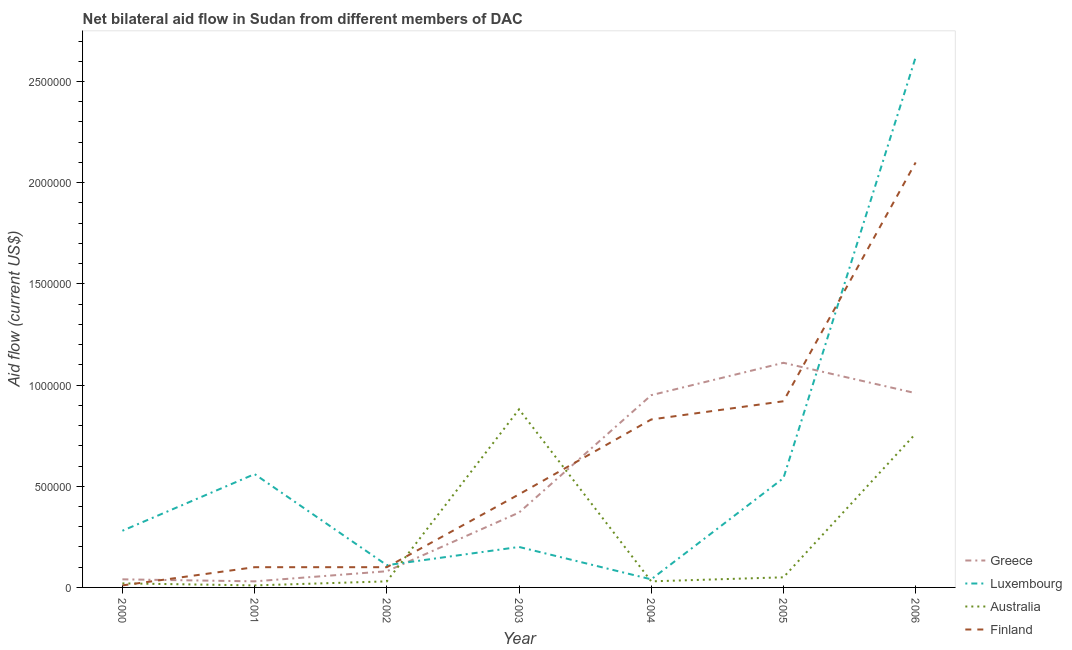How many different coloured lines are there?
Provide a succinct answer. 4. Does the line corresponding to amount of aid given by finland intersect with the line corresponding to amount of aid given by greece?
Your response must be concise. Yes. What is the amount of aid given by luxembourg in 2003?
Keep it short and to the point. 2.00e+05. Across all years, what is the maximum amount of aid given by australia?
Offer a terse response. 8.80e+05. Across all years, what is the minimum amount of aid given by australia?
Offer a very short reply. 10000. In which year was the amount of aid given by luxembourg minimum?
Your response must be concise. 2004. What is the total amount of aid given by australia in the graph?
Your response must be concise. 1.78e+06. What is the difference between the amount of aid given by luxembourg in 2000 and that in 2005?
Provide a short and direct response. -2.60e+05. What is the difference between the amount of aid given by luxembourg in 2004 and the amount of aid given by australia in 2005?
Offer a very short reply. -10000. What is the average amount of aid given by finland per year?
Offer a terse response. 6.46e+05. In the year 2001, what is the difference between the amount of aid given by greece and amount of aid given by finland?
Make the answer very short. -7.00e+04. What is the ratio of the amount of aid given by luxembourg in 2003 to that in 2004?
Offer a very short reply. 5. Is the amount of aid given by finland in 2000 less than that in 2004?
Your answer should be very brief. Yes. What is the difference between the highest and the second highest amount of aid given by luxembourg?
Give a very brief answer. 2.06e+06. What is the difference between the highest and the lowest amount of aid given by australia?
Your answer should be compact. 8.70e+05. In how many years, is the amount of aid given by australia greater than the average amount of aid given by australia taken over all years?
Give a very brief answer. 2. Is the sum of the amount of aid given by australia in 2001 and 2003 greater than the maximum amount of aid given by greece across all years?
Your answer should be compact. No. Is it the case that in every year, the sum of the amount of aid given by greece and amount of aid given by luxembourg is greater than the amount of aid given by australia?
Your answer should be very brief. No. Is the amount of aid given by luxembourg strictly less than the amount of aid given by australia over the years?
Your answer should be compact. No. How many lines are there?
Provide a short and direct response. 4. How many years are there in the graph?
Give a very brief answer. 7. What is the difference between two consecutive major ticks on the Y-axis?
Your answer should be very brief. 5.00e+05. Are the values on the major ticks of Y-axis written in scientific E-notation?
Offer a very short reply. No. How many legend labels are there?
Keep it short and to the point. 4. How are the legend labels stacked?
Provide a succinct answer. Vertical. What is the title of the graph?
Provide a succinct answer. Net bilateral aid flow in Sudan from different members of DAC. Does "Overall level" appear as one of the legend labels in the graph?
Your answer should be very brief. No. What is the label or title of the X-axis?
Your answer should be compact. Year. What is the Aid flow (current US$) in Finland in 2000?
Offer a terse response. 10000. What is the Aid flow (current US$) in Luxembourg in 2001?
Provide a succinct answer. 5.60e+05. What is the Aid flow (current US$) of Finland in 2001?
Ensure brevity in your answer.  1.00e+05. What is the Aid flow (current US$) in Greece in 2002?
Your answer should be very brief. 8.00e+04. What is the Aid flow (current US$) in Australia in 2003?
Ensure brevity in your answer.  8.80e+05. What is the Aid flow (current US$) of Greece in 2004?
Make the answer very short. 9.50e+05. What is the Aid flow (current US$) in Australia in 2004?
Offer a terse response. 3.00e+04. What is the Aid flow (current US$) of Finland in 2004?
Provide a succinct answer. 8.30e+05. What is the Aid flow (current US$) of Greece in 2005?
Your answer should be compact. 1.11e+06. What is the Aid flow (current US$) of Luxembourg in 2005?
Keep it short and to the point. 5.40e+05. What is the Aid flow (current US$) of Finland in 2005?
Give a very brief answer. 9.20e+05. What is the Aid flow (current US$) of Greece in 2006?
Ensure brevity in your answer.  9.60e+05. What is the Aid flow (current US$) of Luxembourg in 2006?
Make the answer very short. 2.62e+06. What is the Aid flow (current US$) in Australia in 2006?
Keep it short and to the point. 7.60e+05. What is the Aid flow (current US$) in Finland in 2006?
Your answer should be very brief. 2.10e+06. Across all years, what is the maximum Aid flow (current US$) in Greece?
Make the answer very short. 1.11e+06. Across all years, what is the maximum Aid flow (current US$) of Luxembourg?
Your answer should be very brief. 2.62e+06. Across all years, what is the maximum Aid flow (current US$) in Australia?
Ensure brevity in your answer.  8.80e+05. Across all years, what is the maximum Aid flow (current US$) in Finland?
Give a very brief answer. 2.10e+06. Across all years, what is the minimum Aid flow (current US$) in Greece?
Offer a terse response. 3.00e+04. Across all years, what is the minimum Aid flow (current US$) of Australia?
Offer a terse response. 10000. What is the total Aid flow (current US$) in Greece in the graph?
Ensure brevity in your answer.  3.54e+06. What is the total Aid flow (current US$) in Luxembourg in the graph?
Make the answer very short. 4.35e+06. What is the total Aid flow (current US$) of Australia in the graph?
Ensure brevity in your answer.  1.78e+06. What is the total Aid flow (current US$) in Finland in the graph?
Ensure brevity in your answer.  4.52e+06. What is the difference between the Aid flow (current US$) of Luxembourg in 2000 and that in 2001?
Offer a very short reply. -2.80e+05. What is the difference between the Aid flow (current US$) in Australia in 2000 and that in 2001?
Keep it short and to the point. 10000. What is the difference between the Aid flow (current US$) in Finland in 2000 and that in 2001?
Your answer should be compact. -9.00e+04. What is the difference between the Aid flow (current US$) of Luxembourg in 2000 and that in 2002?
Your response must be concise. 1.70e+05. What is the difference between the Aid flow (current US$) in Australia in 2000 and that in 2002?
Your answer should be very brief. -10000. What is the difference between the Aid flow (current US$) in Greece in 2000 and that in 2003?
Your answer should be very brief. -3.30e+05. What is the difference between the Aid flow (current US$) in Australia in 2000 and that in 2003?
Offer a very short reply. -8.60e+05. What is the difference between the Aid flow (current US$) in Finland in 2000 and that in 2003?
Give a very brief answer. -4.50e+05. What is the difference between the Aid flow (current US$) in Greece in 2000 and that in 2004?
Keep it short and to the point. -9.10e+05. What is the difference between the Aid flow (current US$) in Luxembourg in 2000 and that in 2004?
Your answer should be very brief. 2.40e+05. What is the difference between the Aid flow (current US$) in Australia in 2000 and that in 2004?
Your response must be concise. -10000. What is the difference between the Aid flow (current US$) of Finland in 2000 and that in 2004?
Keep it short and to the point. -8.20e+05. What is the difference between the Aid flow (current US$) of Greece in 2000 and that in 2005?
Offer a very short reply. -1.07e+06. What is the difference between the Aid flow (current US$) in Finland in 2000 and that in 2005?
Ensure brevity in your answer.  -9.10e+05. What is the difference between the Aid flow (current US$) of Greece in 2000 and that in 2006?
Your response must be concise. -9.20e+05. What is the difference between the Aid flow (current US$) of Luxembourg in 2000 and that in 2006?
Your answer should be very brief. -2.34e+06. What is the difference between the Aid flow (current US$) of Australia in 2000 and that in 2006?
Keep it short and to the point. -7.40e+05. What is the difference between the Aid flow (current US$) in Finland in 2000 and that in 2006?
Give a very brief answer. -2.09e+06. What is the difference between the Aid flow (current US$) of Australia in 2001 and that in 2002?
Offer a terse response. -2.00e+04. What is the difference between the Aid flow (current US$) in Finland in 2001 and that in 2002?
Keep it short and to the point. 0. What is the difference between the Aid flow (current US$) in Greece in 2001 and that in 2003?
Your response must be concise. -3.40e+05. What is the difference between the Aid flow (current US$) of Luxembourg in 2001 and that in 2003?
Give a very brief answer. 3.60e+05. What is the difference between the Aid flow (current US$) in Australia in 2001 and that in 2003?
Provide a short and direct response. -8.70e+05. What is the difference between the Aid flow (current US$) in Finland in 2001 and that in 2003?
Provide a short and direct response. -3.60e+05. What is the difference between the Aid flow (current US$) of Greece in 2001 and that in 2004?
Provide a succinct answer. -9.20e+05. What is the difference between the Aid flow (current US$) of Luxembourg in 2001 and that in 2004?
Keep it short and to the point. 5.20e+05. What is the difference between the Aid flow (current US$) in Finland in 2001 and that in 2004?
Offer a terse response. -7.30e+05. What is the difference between the Aid flow (current US$) of Greece in 2001 and that in 2005?
Give a very brief answer. -1.08e+06. What is the difference between the Aid flow (current US$) in Australia in 2001 and that in 2005?
Make the answer very short. -4.00e+04. What is the difference between the Aid flow (current US$) in Finland in 2001 and that in 2005?
Your answer should be compact. -8.20e+05. What is the difference between the Aid flow (current US$) of Greece in 2001 and that in 2006?
Give a very brief answer. -9.30e+05. What is the difference between the Aid flow (current US$) of Luxembourg in 2001 and that in 2006?
Your answer should be very brief. -2.06e+06. What is the difference between the Aid flow (current US$) of Australia in 2001 and that in 2006?
Offer a terse response. -7.50e+05. What is the difference between the Aid flow (current US$) of Finland in 2001 and that in 2006?
Offer a very short reply. -2.00e+06. What is the difference between the Aid flow (current US$) in Greece in 2002 and that in 2003?
Your answer should be compact. -2.90e+05. What is the difference between the Aid flow (current US$) in Australia in 2002 and that in 2003?
Make the answer very short. -8.50e+05. What is the difference between the Aid flow (current US$) in Finland in 2002 and that in 2003?
Provide a succinct answer. -3.60e+05. What is the difference between the Aid flow (current US$) in Greece in 2002 and that in 2004?
Provide a succinct answer. -8.70e+05. What is the difference between the Aid flow (current US$) in Luxembourg in 2002 and that in 2004?
Keep it short and to the point. 7.00e+04. What is the difference between the Aid flow (current US$) in Finland in 2002 and that in 2004?
Offer a terse response. -7.30e+05. What is the difference between the Aid flow (current US$) in Greece in 2002 and that in 2005?
Keep it short and to the point. -1.03e+06. What is the difference between the Aid flow (current US$) in Luxembourg in 2002 and that in 2005?
Offer a terse response. -4.30e+05. What is the difference between the Aid flow (current US$) of Finland in 2002 and that in 2005?
Your answer should be compact. -8.20e+05. What is the difference between the Aid flow (current US$) in Greece in 2002 and that in 2006?
Your answer should be very brief. -8.80e+05. What is the difference between the Aid flow (current US$) in Luxembourg in 2002 and that in 2006?
Make the answer very short. -2.51e+06. What is the difference between the Aid flow (current US$) in Australia in 2002 and that in 2006?
Ensure brevity in your answer.  -7.30e+05. What is the difference between the Aid flow (current US$) in Greece in 2003 and that in 2004?
Keep it short and to the point. -5.80e+05. What is the difference between the Aid flow (current US$) in Luxembourg in 2003 and that in 2004?
Offer a very short reply. 1.60e+05. What is the difference between the Aid flow (current US$) of Australia in 2003 and that in 2004?
Make the answer very short. 8.50e+05. What is the difference between the Aid flow (current US$) in Finland in 2003 and that in 2004?
Your response must be concise. -3.70e+05. What is the difference between the Aid flow (current US$) of Greece in 2003 and that in 2005?
Your response must be concise. -7.40e+05. What is the difference between the Aid flow (current US$) of Luxembourg in 2003 and that in 2005?
Your answer should be very brief. -3.40e+05. What is the difference between the Aid flow (current US$) of Australia in 2003 and that in 2005?
Provide a succinct answer. 8.30e+05. What is the difference between the Aid flow (current US$) of Finland in 2003 and that in 2005?
Provide a succinct answer. -4.60e+05. What is the difference between the Aid flow (current US$) in Greece in 2003 and that in 2006?
Offer a very short reply. -5.90e+05. What is the difference between the Aid flow (current US$) of Luxembourg in 2003 and that in 2006?
Provide a short and direct response. -2.42e+06. What is the difference between the Aid flow (current US$) in Australia in 2003 and that in 2006?
Make the answer very short. 1.20e+05. What is the difference between the Aid flow (current US$) of Finland in 2003 and that in 2006?
Provide a succinct answer. -1.64e+06. What is the difference between the Aid flow (current US$) of Luxembourg in 2004 and that in 2005?
Offer a terse response. -5.00e+05. What is the difference between the Aid flow (current US$) of Greece in 2004 and that in 2006?
Provide a succinct answer. -10000. What is the difference between the Aid flow (current US$) of Luxembourg in 2004 and that in 2006?
Your response must be concise. -2.58e+06. What is the difference between the Aid flow (current US$) of Australia in 2004 and that in 2006?
Your answer should be very brief. -7.30e+05. What is the difference between the Aid flow (current US$) in Finland in 2004 and that in 2006?
Provide a succinct answer. -1.27e+06. What is the difference between the Aid flow (current US$) in Greece in 2005 and that in 2006?
Offer a terse response. 1.50e+05. What is the difference between the Aid flow (current US$) of Luxembourg in 2005 and that in 2006?
Provide a short and direct response. -2.08e+06. What is the difference between the Aid flow (current US$) of Australia in 2005 and that in 2006?
Offer a terse response. -7.10e+05. What is the difference between the Aid flow (current US$) of Finland in 2005 and that in 2006?
Give a very brief answer. -1.18e+06. What is the difference between the Aid flow (current US$) of Greece in 2000 and the Aid flow (current US$) of Luxembourg in 2001?
Offer a terse response. -5.20e+05. What is the difference between the Aid flow (current US$) in Greece in 2000 and the Aid flow (current US$) in Australia in 2001?
Provide a succinct answer. 3.00e+04. What is the difference between the Aid flow (current US$) of Greece in 2000 and the Aid flow (current US$) of Finland in 2001?
Your answer should be compact. -6.00e+04. What is the difference between the Aid flow (current US$) in Luxembourg in 2000 and the Aid flow (current US$) in Australia in 2001?
Offer a terse response. 2.70e+05. What is the difference between the Aid flow (current US$) in Greece in 2000 and the Aid flow (current US$) in Luxembourg in 2002?
Offer a terse response. -7.00e+04. What is the difference between the Aid flow (current US$) of Greece in 2000 and the Aid flow (current US$) of Finland in 2002?
Offer a very short reply. -6.00e+04. What is the difference between the Aid flow (current US$) in Luxembourg in 2000 and the Aid flow (current US$) in Australia in 2002?
Your answer should be very brief. 2.50e+05. What is the difference between the Aid flow (current US$) in Luxembourg in 2000 and the Aid flow (current US$) in Finland in 2002?
Keep it short and to the point. 1.80e+05. What is the difference between the Aid flow (current US$) in Greece in 2000 and the Aid flow (current US$) in Luxembourg in 2003?
Your answer should be compact. -1.60e+05. What is the difference between the Aid flow (current US$) of Greece in 2000 and the Aid flow (current US$) of Australia in 2003?
Ensure brevity in your answer.  -8.40e+05. What is the difference between the Aid flow (current US$) in Greece in 2000 and the Aid flow (current US$) in Finland in 2003?
Offer a very short reply. -4.20e+05. What is the difference between the Aid flow (current US$) of Luxembourg in 2000 and the Aid flow (current US$) of Australia in 2003?
Ensure brevity in your answer.  -6.00e+05. What is the difference between the Aid flow (current US$) in Australia in 2000 and the Aid flow (current US$) in Finland in 2003?
Your answer should be compact. -4.40e+05. What is the difference between the Aid flow (current US$) in Greece in 2000 and the Aid flow (current US$) in Luxembourg in 2004?
Keep it short and to the point. 0. What is the difference between the Aid flow (current US$) of Greece in 2000 and the Aid flow (current US$) of Australia in 2004?
Provide a succinct answer. 10000. What is the difference between the Aid flow (current US$) in Greece in 2000 and the Aid flow (current US$) in Finland in 2004?
Provide a succinct answer. -7.90e+05. What is the difference between the Aid flow (current US$) of Luxembourg in 2000 and the Aid flow (current US$) of Finland in 2004?
Give a very brief answer. -5.50e+05. What is the difference between the Aid flow (current US$) in Australia in 2000 and the Aid flow (current US$) in Finland in 2004?
Make the answer very short. -8.10e+05. What is the difference between the Aid flow (current US$) of Greece in 2000 and the Aid flow (current US$) of Luxembourg in 2005?
Your answer should be very brief. -5.00e+05. What is the difference between the Aid flow (current US$) of Greece in 2000 and the Aid flow (current US$) of Australia in 2005?
Your response must be concise. -10000. What is the difference between the Aid flow (current US$) in Greece in 2000 and the Aid flow (current US$) in Finland in 2005?
Your response must be concise. -8.80e+05. What is the difference between the Aid flow (current US$) of Luxembourg in 2000 and the Aid flow (current US$) of Finland in 2005?
Provide a succinct answer. -6.40e+05. What is the difference between the Aid flow (current US$) in Australia in 2000 and the Aid flow (current US$) in Finland in 2005?
Your answer should be compact. -9.00e+05. What is the difference between the Aid flow (current US$) of Greece in 2000 and the Aid flow (current US$) of Luxembourg in 2006?
Make the answer very short. -2.58e+06. What is the difference between the Aid flow (current US$) in Greece in 2000 and the Aid flow (current US$) in Australia in 2006?
Offer a terse response. -7.20e+05. What is the difference between the Aid flow (current US$) in Greece in 2000 and the Aid flow (current US$) in Finland in 2006?
Your answer should be compact. -2.06e+06. What is the difference between the Aid flow (current US$) in Luxembourg in 2000 and the Aid flow (current US$) in Australia in 2006?
Your response must be concise. -4.80e+05. What is the difference between the Aid flow (current US$) in Luxembourg in 2000 and the Aid flow (current US$) in Finland in 2006?
Provide a succinct answer. -1.82e+06. What is the difference between the Aid flow (current US$) of Australia in 2000 and the Aid flow (current US$) of Finland in 2006?
Ensure brevity in your answer.  -2.08e+06. What is the difference between the Aid flow (current US$) in Greece in 2001 and the Aid flow (current US$) in Australia in 2002?
Provide a short and direct response. 0. What is the difference between the Aid flow (current US$) in Greece in 2001 and the Aid flow (current US$) in Finland in 2002?
Your answer should be very brief. -7.00e+04. What is the difference between the Aid flow (current US$) of Luxembourg in 2001 and the Aid flow (current US$) of Australia in 2002?
Ensure brevity in your answer.  5.30e+05. What is the difference between the Aid flow (current US$) of Luxembourg in 2001 and the Aid flow (current US$) of Finland in 2002?
Offer a very short reply. 4.60e+05. What is the difference between the Aid flow (current US$) of Australia in 2001 and the Aid flow (current US$) of Finland in 2002?
Keep it short and to the point. -9.00e+04. What is the difference between the Aid flow (current US$) of Greece in 2001 and the Aid flow (current US$) of Australia in 2003?
Give a very brief answer. -8.50e+05. What is the difference between the Aid flow (current US$) in Greece in 2001 and the Aid flow (current US$) in Finland in 2003?
Provide a short and direct response. -4.30e+05. What is the difference between the Aid flow (current US$) of Luxembourg in 2001 and the Aid flow (current US$) of Australia in 2003?
Provide a short and direct response. -3.20e+05. What is the difference between the Aid flow (current US$) of Luxembourg in 2001 and the Aid flow (current US$) of Finland in 2003?
Your answer should be very brief. 1.00e+05. What is the difference between the Aid flow (current US$) in Australia in 2001 and the Aid flow (current US$) in Finland in 2003?
Make the answer very short. -4.50e+05. What is the difference between the Aid flow (current US$) in Greece in 2001 and the Aid flow (current US$) in Finland in 2004?
Ensure brevity in your answer.  -8.00e+05. What is the difference between the Aid flow (current US$) in Luxembourg in 2001 and the Aid flow (current US$) in Australia in 2004?
Your answer should be compact. 5.30e+05. What is the difference between the Aid flow (current US$) in Luxembourg in 2001 and the Aid flow (current US$) in Finland in 2004?
Your answer should be compact. -2.70e+05. What is the difference between the Aid flow (current US$) of Australia in 2001 and the Aid flow (current US$) of Finland in 2004?
Your answer should be very brief. -8.20e+05. What is the difference between the Aid flow (current US$) in Greece in 2001 and the Aid flow (current US$) in Luxembourg in 2005?
Provide a short and direct response. -5.10e+05. What is the difference between the Aid flow (current US$) of Greece in 2001 and the Aid flow (current US$) of Australia in 2005?
Offer a very short reply. -2.00e+04. What is the difference between the Aid flow (current US$) in Greece in 2001 and the Aid flow (current US$) in Finland in 2005?
Provide a succinct answer. -8.90e+05. What is the difference between the Aid flow (current US$) of Luxembourg in 2001 and the Aid flow (current US$) of Australia in 2005?
Offer a terse response. 5.10e+05. What is the difference between the Aid flow (current US$) in Luxembourg in 2001 and the Aid flow (current US$) in Finland in 2005?
Your answer should be compact. -3.60e+05. What is the difference between the Aid flow (current US$) in Australia in 2001 and the Aid flow (current US$) in Finland in 2005?
Your answer should be very brief. -9.10e+05. What is the difference between the Aid flow (current US$) in Greece in 2001 and the Aid flow (current US$) in Luxembourg in 2006?
Your response must be concise. -2.59e+06. What is the difference between the Aid flow (current US$) in Greece in 2001 and the Aid flow (current US$) in Australia in 2006?
Your response must be concise. -7.30e+05. What is the difference between the Aid flow (current US$) in Greece in 2001 and the Aid flow (current US$) in Finland in 2006?
Provide a succinct answer. -2.07e+06. What is the difference between the Aid flow (current US$) in Luxembourg in 2001 and the Aid flow (current US$) in Australia in 2006?
Provide a succinct answer. -2.00e+05. What is the difference between the Aid flow (current US$) in Luxembourg in 2001 and the Aid flow (current US$) in Finland in 2006?
Ensure brevity in your answer.  -1.54e+06. What is the difference between the Aid flow (current US$) of Australia in 2001 and the Aid flow (current US$) of Finland in 2006?
Ensure brevity in your answer.  -2.09e+06. What is the difference between the Aid flow (current US$) in Greece in 2002 and the Aid flow (current US$) in Australia in 2003?
Offer a terse response. -8.00e+05. What is the difference between the Aid flow (current US$) in Greece in 2002 and the Aid flow (current US$) in Finland in 2003?
Ensure brevity in your answer.  -3.80e+05. What is the difference between the Aid flow (current US$) in Luxembourg in 2002 and the Aid flow (current US$) in Australia in 2003?
Provide a succinct answer. -7.70e+05. What is the difference between the Aid flow (current US$) in Luxembourg in 2002 and the Aid flow (current US$) in Finland in 2003?
Offer a very short reply. -3.50e+05. What is the difference between the Aid flow (current US$) in Australia in 2002 and the Aid flow (current US$) in Finland in 2003?
Ensure brevity in your answer.  -4.30e+05. What is the difference between the Aid flow (current US$) in Greece in 2002 and the Aid flow (current US$) in Finland in 2004?
Make the answer very short. -7.50e+05. What is the difference between the Aid flow (current US$) in Luxembourg in 2002 and the Aid flow (current US$) in Finland in 2004?
Provide a succinct answer. -7.20e+05. What is the difference between the Aid flow (current US$) in Australia in 2002 and the Aid flow (current US$) in Finland in 2004?
Offer a very short reply. -8.00e+05. What is the difference between the Aid flow (current US$) in Greece in 2002 and the Aid flow (current US$) in Luxembourg in 2005?
Offer a very short reply. -4.60e+05. What is the difference between the Aid flow (current US$) of Greece in 2002 and the Aid flow (current US$) of Finland in 2005?
Ensure brevity in your answer.  -8.40e+05. What is the difference between the Aid flow (current US$) of Luxembourg in 2002 and the Aid flow (current US$) of Australia in 2005?
Provide a short and direct response. 6.00e+04. What is the difference between the Aid flow (current US$) of Luxembourg in 2002 and the Aid flow (current US$) of Finland in 2005?
Offer a very short reply. -8.10e+05. What is the difference between the Aid flow (current US$) of Australia in 2002 and the Aid flow (current US$) of Finland in 2005?
Provide a short and direct response. -8.90e+05. What is the difference between the Aid flow (current US$) of Greece in 2002 and the Aid flow (current US$) of Luxembourg in 2006?
Provide a short and direct response. -2.54e+06. What is the difference between the Aid flow (current US$) of Greece in 2002 and the Aid flow (current US$) of Australia in 2006?
Provide a succinct answer. -6.80e+05. What is the difference between the Aid flow (current US$) in Greece in 2002 and the Aid flow (current US$) in Finland in 2006?
Provide a succinct answer. -2.02e+06. What is the difference between the Aid flow (current US$) of Luxembourg in 2002 and the Aid flow (current US$) of Australia in 2006?
Provide a short and direct response. -6.50e+05. What is the difference between the Aid flow (current US$) of Luxembourg in 2002 and the Aid flow (current US$) of Finland in 2006?
Give a very brief answer. -1.99e+06. What is the difference between the Aid flow (current US$) of Australia in 2002 and the Aid flow (current US$) of Finland in 2006?
Your response must be concise. -2.07e+06. What is the difference between the Aid flow (current US$) in Greece in 2003 and the Aid flow (current US$) in Luxembourg in 2004?
Make the answer very short. 3.30e+05. What is the difference between the Aid flow (current US$) of Greece in 2003 and the Aid flow (current US$) of Finland in 2004?
Keep it short and to the point. -4.60e+05. What is the difference between the Aid flow (current US$) of Luxembourg in 2003 and the Aid flow (current US$) of Finland in 2004?
Give a very brief answer. -6.30e+05. What is the difference between the Aid flow (current US$) of Greece in 2003 and the Aid flow (current US$) of Australia in 2005?
Keep it short and to the point. 3.20e+05. What is the difference between the Aid flow (current US$) in Greece in 2003 and the Aid flow (current US$) in Finland in 2005?
Your answer should be very brief. -5.50e+05. What is the difference between the Aid flow (current US$) in Luxembourg in 2003 and the Aid flow (current US$) in Australia in 2005?
Ensure brevity in your answer.  1.50e+05. What is the difference between the Aid flow (current US$) of Luxembourg in 2003 and the Aid flow (current US$) of Finland in 2005?
Offer a terse response. -7.20e+05. What is the difference between the Aid flow (current US$) in Australia in 2003 and the Aid flow (current US$) in Finland in 2005?
Offer a very short reply. -4.00e+04. What is the difference between the Aid flow (current US$) in Greece in 2003 and the Aid flow (current US$) in Luxembourg in 2006?
Offer a terse response. -2.25e+06. What is the difference between the Aid flow (current US$) in Greece in 2003 and the Aid flow (current US$) in Australia in 2006?
Ensure brevity in your answer.  -3.90e+05. What is the difference between the Aid flow (current US$) of Greece in 2003 and the Aid flow (current US$) of Finland in 2006?
Ensure brevity in your answer.  -1.73e+06. What is the difference between the Aid flow (current US$) in Luxembourg in 2003 and the Aid flow (current US$) in Australia in 2006?
Keep it short and to the point. -5.60e+05. What is the difference between the Aid flow (current US$) in Luxembourg in 2003 and the Aid flow (current US$) in Finland in 2006?
Ensure brevity in your answer.  -1.90e+06. What is the difference between the Aid flow (current US$) of Australia in 2003 and the Aid flow (current US$) of Finland in 2006?
Your answer should be very brief. -1.22e+06. What is the difference between the Aid flow (current US$) of Greece in 2004 and the Aid flow (current US$) of Luxembourg in 2005?
Your response must be concise. 4.10e+05. What is the difference between the Aid flow (current US$) in Greece in 2004 and the Aid flow (current US$) in Australia in 2005?
Provide a short and direct response. 9.00e+05. What is the difference between the Aid flow (current US$) of Greece in 2004 and the Aid flow (current US$) of Finland in 2005?
Provide a short and direct response. 3.00e+04. What is the difference between the Aid flow (current US$) of Luxembourg in 2004 and the Aid flow (current US$) of Finland in 2005?
Your answer should be very brief. -8.80e+05. What is the difference between the Aid flow (current US$) in Australia in 2004 and the Aid flow (current US$) in Finland in 2005?
Offer a very short reply. -8.90e+05. What is the difference between the Aid flow (current US$) in Greece in 2004 and the Aid flow (current US$) in Luxembourg in 2006?
Provide a short and direct response. -1.67e+06. What is the difference between the Aid flow (current US$) in Greece in 2004 and the Aid flow (current US$) in Finland in 2006?
Give a very brief answer. -1.15e+06. What is the difference between the Aid flow (current US$) of Luxembourg in 2004 and the Aid flow (current US$) of Australia in 2006?
Provide a short and direct response. -7.20e+05. What is the difference between the Aid flow (current US$) in Luxembourg in 2004 and the Aid flow (current US$) in Finland in 2006?
Keep it short and to the point. -2.06e+06. What is the difference between the Aid flow (current US$) of Australia in 2004 and the Aid flow (current US$) of Finland in 2006?
Offer a very short reply. -2.07e+06. What is the difference between the Aid flow (current US$) in Greece in 2005 and the Aid flow (current US$) in Luxembourg in 2006?
Your answer should be very brief. -1.51e+06. What is the difference between the Aid flow (current US$) of Greece in 2005 and the Aid flow (current US$) of Finland in 2006?
Your answer should be very brief. -9.90e+05. What is the difference between the Aid flow (current US$) in Luxembourg in 2005 and the Aid flow (current US$) in Australia in 2006?
Your answer should be compact. -2.20e+05. What is the difference between the Aid flow (current US$) in Luxembourg in 2005 and the Aid flow (current US$) in Finland in 2006?
Offer a terse response. -1.56e+06. What is the difference between the Aid flow (current US$) in Australia in 2005 and the Aid flow (current US$) in Finland in 2006?
Make the answer very short. -2.05e+06. What is the average Aid flow (current US$) of Greece per year?
Offer a very short reply. 5.06e+05. What is the average Aid flow (current US$) in Luxembourg per year?
Your response must be concise. 6.21e+05. What is the average Aid flow (current US$) in Australia per year?
Make the answer very short. 2.54e+05. What is the average Aid flow (current US$) in Finland per year?
Your answer should be compact. 6.46e+05. In the year 2000, what is the difference between the Aid flow (current US$) of Luxembourg and Aid flow (current US$) of Finland?
Make the answer very short. 2.70e+05. In the year 2001, what is the difference between the Aid flow (current US$) in Greece and Aid flow (current US$) in Luxembourg?
Provide a short and direct response. -5.30e+05. In the year 2001, what is the difference between the Aid flow (current US$) in Australia and Aid flow (current US$) in Finland?
Make the answer very short. -9.00e+04. In the year 2002, what is the difference between the Aid flow (current US$) of Greece and Aid flow (current US$) of Finland?
Provide a short and direct response. -2.00e+04. In the year 2002, what is the difference between the Aid flow (current US$) of Luxembourg and Aid flow (current US$) of Australia?
Your answer should be very brief. 8.00e+04. In the year 2002, what is the difference between the Aid flow (current US$) of Australia and Aid flow (current US$) of Finland?
Keep it short and to the point. -7.00e+04. In the year 2003, what is the difference between the Aid flow (current US$) in Greece and Aid flow (current US$) in Luxembourg?
Offer a terse response. 1.70e+05. In the year 2003, what is the difference between the Aid flow (current US$) in Greece and Aid flow (current US$) in Australia?
Offer a very short reply. -5.10e+05. In the year 2003, what is the difference between the Aid flow (current US$) of Greece and Aid flow (current US$) of Finland?
Your answer should be compact. -9.00e+04. In the year 2003, what is the difference between the Aid flow (current US$) in Luxembourg and Aid flow (current US$) in Australia?
Offer a very short reply. -6.80e+05. In the year 2003, what is the difference between the Aid flow (current US$) in Australia and Aid flow (current US$) in Finland?
Give a very brief answer. 4.20e+05. In the year 2004, what is the difference between the Aid flow (current US$) of Greece and Aid flow (current US$) of Luxembourg?
Give a very brief answer. 9.10e+05. In the year 2004, what is the difference between the Aid flow (current US$) in Greece and Aid flow (current US$) in Australia?
Your answer should be compact. 9.20e+05. In the year 2004, what is the difference between the Aid flow (current US$) in Greece and Aid flow (current US$) in Finland?
Provide a short and direct response. 1.20e+05. In the year 2004, what is the difference between the Aid flow (current US$) of Luxembourg and Aid flow (current US$) of Finland?
Make the answer very short. -7.90e+05. In the year 2004, what is the difference between the Aid flow (current US$) of Australia and Aid flow (current US$) of Finland?
Give a very brief answer. -8.00e+05. In the year 2005, what is the difference between the Aid flow (current US$) in Greece and Aid flow (current US$) in Luxembourg?
Your answer should be compact. 5.70e+05. In the year 2005, what is the difference between the Aid flow (current US$) of Greece and Aid flow (current US$) of Australia?
Ensure brevity in your answer.  1.06e+06. In the year 2005, what is the difference between the Aid flow (current US$) of Greece and Aid flow (current US$) of Finland?
Provide a short and direct response. 1.90e+05. In the year 2005, what is the difference between the Aid flow (current US$) of Luxembourg and Aid flow (current US$) of Australia?
Provide a succinct answer. 4.90e+05. In the year 2005, what is the difference between the Aid flow (current US$) in Luxembourg and Aid flow (current US$) in Finland?
Your answer should be very brief. -3.80e+05. In the year 2005, what is the difference between the Aid flow (current US$) in Australia and Aid flow (current US$) in Finland?
Provide a succinct answer. -8.70e+05. In the year 2006, what is the difference between the Aid flow (current US$) in Greece and Aid flow (current US$) in Luxembourg?
Ensure brevity in your answer.  -1.66e+06. In the year 2006, what is the difference between the Aid flow (current US$) in Greece and Aid flow (current US$) in Finland?
Offer a terse response. -1.14e+06. In the year 2006, what is the difference between the Aid flow (current US$) of Luxembourg and Aid flow (current US$) of Australia?
Offer a terse response. 1.86e+06. In the year 2006, what is the difference between the Aid flow (current US$) in Luxembourg and Aid flow (current US$) in Finland?
Your answer should be very brief. 5.20e+05. In the year 2006, what is the difference between the Aid flow (current US$) in Australia and Aid flow (current US$) in Finland?
Your answer should be very brief. -1.34e+06. What is the ratio of the Aid flow (current US$) of Australia in 2000 to that in 2001?
Your answer should be very brief. 2. What is the ratio of the Aid flow (current US$) of Luxembourg in 2000 to that in 2002?
Provide a succinct answer. 2.55. What is the ratio of the Aid flow (current US$) of Australia in 2000 to that in 2002?
Your answer should be compact. 0.67. What is the ratio of the Aid flow (current US$) of Finland in 2000 to that in 2002?
Offer a very short reply. 0.1. What is the ratio of the Aid flow (current US$) in Greece in 2000 to that in 2003?
Offer a very short reply. 0.11. What is the ratio of the Aid flow (current US$) in Australia in 2000 to that in 2003?
Offer a very short reply. 0.02. What is the ratio of the Aid flow (current US$) of Finland in 2000 to that in 2003?
Your response must be concise. 0.02. What is the ratio of the Aid flow (current US$) of Greece in 2000 to that in 2004?
Provide a short and direct response. 0.04. What is the ratio of the Aid flow (current US$) in Luxembourg in 2000 to that in 2004?
Your answer should be compact. 7. What is the ratio of the Aid flow (current US$) of Australia in 2000 to that in 2004?
Your answer should be compact. 0.67. What is the ratio of the Aid flow (current US$) of Finland in 2000 to that in 2004?
Ensure brevity in your answer.  0.01. What is the ratio of the Aid flow (current US$) in Greece in 2000 to that in 2005?
Offer a very short reply. 0.04. What is the ratio of the Aid flow (current US$) in Luxembourg in 2000 to that in 2005?
Your answer should be very brief. 0.52. What is the ratio of the Aid flow (current US$) of Finland in 2000 to that in 2005?
Make the answer very short. 0.01. What is the ratio of the Aid flow (current US$) in Greece in 2000 to that in 2006?
Make the answer very short. 0.04. What is the ratio of the Aid flow (current US$) in Luxembourg in 2000 to that in 2006?
Your answer should be compact. 0.11. What is the ratio of the Aid flow (current US$) of Australia in 2000 to that in 2006?
Provide a short and direct response. 0.03. What is the ratio of the Aid flow (current US$) in Finland in 2000 to that in 2006?
Offer a very short reply. 0. What is the ratio of the Aid flow (current US$) in Greece in 2001 to that in 2002?
Offer a terse response. 0.38. What is the ratio of the Aid flow (current US$) of Luxembourg in 2001 to that in 2002?
Make the answer very short. 5.09. What is the ratio of the Aid flow (current US$) in Australia in 2001 to that in 2002?
Offer a very short reply. 0.33. What is the ratio of the Aid flow (current US$) of Finland in 2001 to that in 2002?
Offer a very short reply. 1. What is the ratio of the Aid flow (current US$) in Greece in 2001 to that in 2003?
Offer a very short reply. 0.08. What is the ratio of the Aid flow (current US$) in Luxembourg in 2001 to that in 2003?
Provide a succinct answer. 2.8. What is the ratio of the Aid flow (current US$) in Australia in 2001 to that in 2003?
Keep it short and to the point. 0.01. What is the ratio of the Aid flow (current US$) of Finland in 2001 to that in 2003?
Make the answer very short. 0.22. What is the ratio of the Aid flow (current US$) of Greece in 2001 to that in 2004?
Offer a very short reply. 0.03. What is the ratio of the Aid flow (current US$) of Finland in 2001 to that in 2004?
Offer a terse response. 0.12. What is the ratio of the Aid flow (current US$) in Greece in 2001 to that in 2005?
Keep it short and to the point. 0.03. What is the ratio of the Aid flow (current US$) in Luxembourg in 2001 to that in 2005?
Provide a short and direct response. 1.04. What is the ratio of the Aid flow (current US$) in Finland in 2001 to that in 2005?
Keep it short and to the point. 0.11. What is the ratio of the Aid flow (current US$) in Greece in 2001 to that in 2006?
Provide a succinct answer. 0.03. What is the ratio of the Aid flow (current US$) in Luxembourg in 2001 to that in 2006?
Your answer should be compact. 0.21. What is the ratio of the Aid flow (current US$) in Australia in 2001 to that in 2006?
Keep it short and to the point. 0.01. What is the ratio of the Aid flow (current US$) of Finland in 2001 to that in 2006?
Your answer should be very brief. 0.05. What is the ratio of the Aid flow (current US$) in Greece in 2002 to that in 2003?
Give a very brief answer. 0.22. What is the ratio of the Aid flow (current US$) in Luxembourg in 2002 to that in 2003?
Provide a short and direct response. 0.55. What is the ratio of the Aid flow (current US$) in Australia in 2002 to that in 2003?
Offer a very short reply. 0.03. What is the ratio of the Aid flow (current US$) in Finland in 2002 to that in 2003?
Ensure brevity in your answer.  0.22. What is the ratio of the Aid flow (current US$) in Greece in 2002 to that in 2004?
Your answer should be compact. 0.08. What is the ratio of the Aid flow (current US$) in Luxembourg in 2002 to that in 2004?
Your answer should be compact. 2.75. What is the ratio of the Aid flow (current US$) in Finland in 2002 to that in 2004?
Make the answer very short. 0.12. What is the ratio of the Aid flow (current US$) of Greece in 2002 to that in 2005?
Your answer should be very brief. 0.07. What is the ratio of the Aid flow (current US$) in Luxembourg in 2002 to that in 2005?
Offer a very short reply. 0.2. What is the ratio of the Aid flow (current US$) in Australia in 2002 to that in 2005?
Make the answer very short. 0.6. What is the ratio of the Aid flow (current US$) of Finland in 2002 to that in 2005?
Your response must be concise. 0.11. What is the ratio of the Aid flow (current US$) of Greece in 2002 to that in 2006?
Your answer should be very brief. 0.08. What is the ratio of the Aid flow (current US$) in Luxembourg in 2002 to that in 2006?
Offer a terse response. 0.04. What is the ratio of the Aid flow (current US$) of Australia in 2002 to that in 2006?
Make the answer very short. 0.04. What is the ratio of the Aid flow (current US$) of Finland in 2002 to that in 2006?
Your answer should be very brief. 0.05. What is the ratio of the Aid flow (current US$) of Greece in 2003 to that in 2004?
Keep it short and to the point. 0.39. What is the ratio of the Aid flow (current US$) of Australia in 2003 to that in 2004?
Your answer should be compact. 29.33. What is the ratio of the Aid flow (current US$) of Finland in 2003 to that in 2004?
Offer a terse response. 0.55. What is the ratio of the Aid flow (current US$) in Greece in 2003 to that in 2005?
Give a very brief answer. 0.33. What is the ratio of the Aid flow (current US$) in Luxembourg in 2003 to that in 2005?
Your answer should be compact. 0.37. What is the ratio of the Aid flow (current US$) of Finland in 2003 to that in 2005?
Give a very brief answer. 0.5. What is the ratio of the Aid flow (current US$) of Greece in 2003 to that in 2006?
Provide a succinct answer. 0.39. What is the ratio of the Aid flow (current US$) of Luxembourg in 2003 to that in 2006?
Your answer should be compact. 0.08. What is the ratio of the Aid flow (current US$) in Australia in 2003 to that in 2006?
Provide a succinct answer. 1.16. What is the ratio of the Aid flow (current US$) of Finland in 2003 to that in 2006?
Give a very brief answer. 0.22. What is the ratio of the Aid flow (current US$) in Greece in 2004 to that in 2005?
Provide a succinct answer. 0.86. What is the ratio of the Aid flow (current US$) of Luxembourg in 2004 to that in 2005?
Provide a succinct answer. 0.07. What is the ratio of the Aid flow (current US$) of Australia in 2004 to that in 2005?
Your answer should be compact. 0.6. What is the ratio of the Aid flow (current US$) in Finland in 2004 to that in 2005?
Your answer should be compact. 0.9. What is the ratio of the Aid flow (current US$) in Greece in 2004 to that in 2006?
Give a very brief answer. 0.99. What is the ratio of the Aid flow (current US$) of Luxembourg in 2004 to that in 2006?
Keep it short and to the point. 0.02. What is the ratio of the Aid flow (current US$) of Australia in 2004 to that in 2006?
Ensure brevity in your answer.  0.04. What is the ratio of the Aid flow (current US$) in Finland in 2004 to that in 2006?
Your answer should be very brief. 0.4. What is the ratio of the Aid flow (current US$) in Greece in 2005 to that in 2006?
Give a very brief answer. 1.16. What is the ratio of the Aid flow (current US$) of Luxembourg in 2005 to that in 2006?
Offer a very short reply. 0.21. What is the ratio of the Aid flow (current US$) in Australia in 2005 to that in 2006?
Give a very brief answer. 0.07. What is the ratio of the Aid flow (current US$) of Finland in 2005 to that in 2006?
Your response must be concise. 0.44. What is the difference between the highest and the second highest Aid flow (current US$) of Luxembourg?
Offer a terse response. 2.06e+06. What is the difference between the highest and the second highest Aid flow (current US$) in Finland?
Keep it short and to the point. 1.18e+06. What is the difference between the highest and the lowest Aid flow (current US$) in Greece?
Your answer should be compact. 1.08e+06. What is the difference between the highest and the lowest Aid flow (current US$) in Luxembourg?
Your answer should be compact. 2.58e+06. What is the difference between the highest and the lowest Aid flow (current US$) in Australia?
Your response must be concise. 8.70e+05. What is the difference between the highest and the lowest Aid flow (current US$) of Finland?
Your response must be concise. 2.09e+06. 